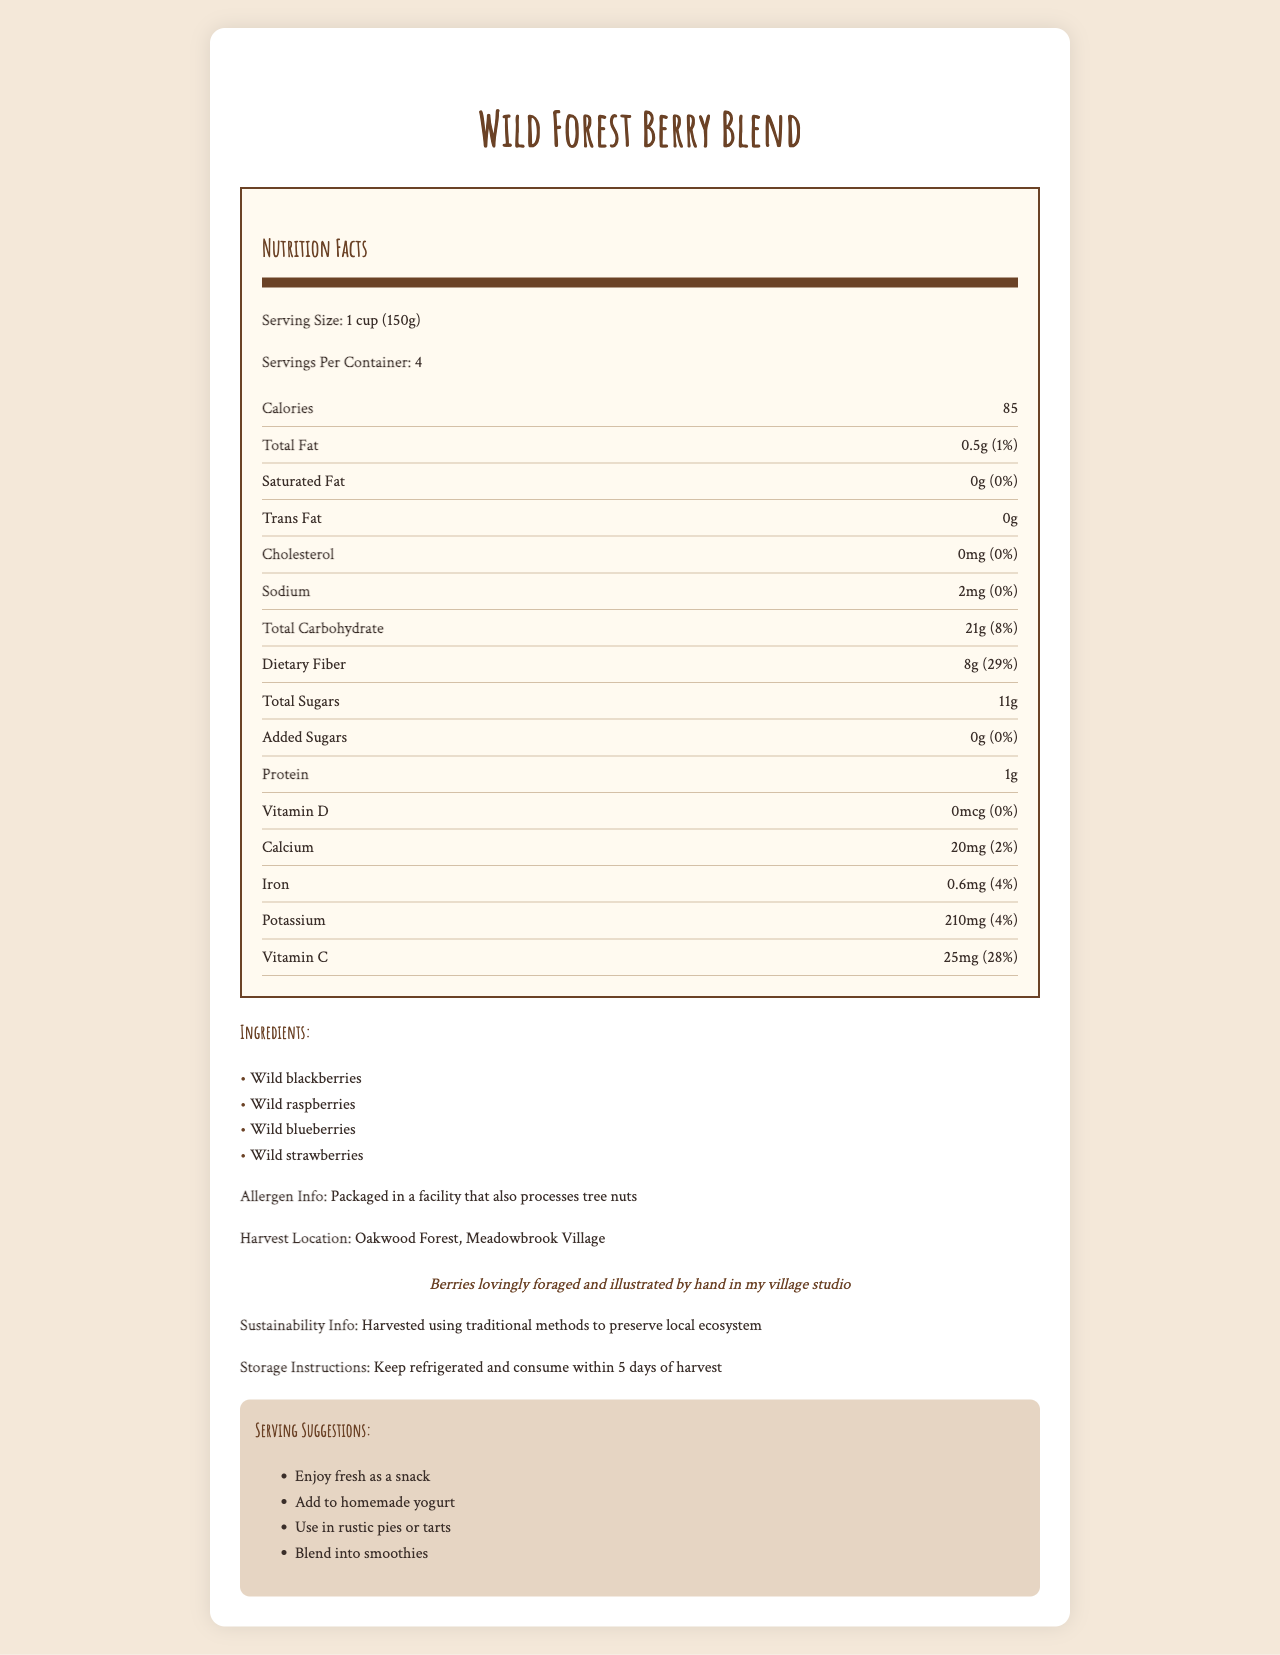What is the serving size for this product? According to the document, the serving size for "Wild Forest Berry Blend" is explicitly mentioned as "1 cup (150g)".
Answer: 1 cup (150g) How many servings are there per container? The document states that there are four servings per container.
Answer: 4 How much Vitamin C is in one serving? The Nutrition Facts show there is 25mg of Vitamin C per serving which equals 28% of the Daily Value.
Answer: 25mg (28% Daily Value) List the berries included in the Wild Forest Berry Blend. The ingredients section lists all the berries included in the blend.
Answer: Wild blackberries, Wild raspberries, Wild blueberries, Wild strawberries What is the amount of dietary fiber per serving? The document specifies the dietary fiber content per serving is 8 grams, which constitutes 29% of the Daily Value.
Answer: 8g (29% Daily Value) Where were the berries harvested? The document mentions that the berries were harvested in Oakwood Forest, Meadowbrook Village.
Answer: Oakwood Forest, Meadowbrook Village Which of the following is true about the total fat content? A. 0g B. 1g C. 0.5g D. 0.2g The document states the total fat content per serving is 0.5g.
Answer: C The hand-drawn illustrations include which type of drawing for blueberries? A. Watercolor painting B. Pencil drawing C. Charcoal sketch D. Ink drawing The document describes the blueberry illustration as a pencil drawing on a branch.
Answer: B Is there added sugar in the Wild Forest Berry Blend? The document states that the added sugars amount to 0g.
Answer: No Summarize the key information provided in this nutrition label document. Describing the entire document reveals comprehensive nutrition information, ingredient details, allergen information, and artistic notes, emphasizing both the nutritional and aesthetic aspects of the product.
Answer: The "Wild Forest Berry Blend" contains various types of wild berries, offering nutritional benefits such as dietary fiber (8g) and Vitamin C (25mg) per serving. It has 85 calories per serving size (1 cup or 150g), with low fat, sodium, and no cholesterol or added sugars. The berries are harvested sustainably from Oakwood Forest and contain possibly mild allergens. This document also includes artistic, hand-drawn illustrations of the individual berries and a forest scene, and it provides several serving suggestions for the blend. What is the calorie content per serving? The nutrition label shows that each serving contains 85 calories.
Answer: 85 calories Which mineral is present in the highest amount? A. Calcium B. Iron C. Potassium D. Vitamin D The document lists potassium at 210mg per serving, which is higher than calcium (20mg), iron (0.6mg), and vitamin D (0mcg).
Answer: C How is the product's sustainability characterized? The document notes that the berries are harvested using traditional methods to maintain the local ecosystem.
Answer: Harvested using traditional methods to preserve the local ecosystem What specific allergen information is provided? The document contains a specific allergen warning stating that the product is packaged in a facility that processes tree nuts.
Answer: Packaged in a facility that also processes tree nuts What is the main idea of the document? By stating this, the document aims to inform the consumer about the health benefits, origin, and artistic aspect of the berry blend.
Answer: To provide detailed nutritional information, ingredient composition, sustainability practices, and serving suggestions for the Wild Forest Berry Blend, along with artistically rendered illustrations of the berries. How much sodium does each serving contain? According to the document, each serving contains 2mg of sodium, which is 0% of the Daily Value.
Answer: 2mg (0% Daily Value) How long can the berries be stored after harvest? The document instructs to keep the berries refrigerated and consume them within 5 days of harvest.
Answer: 5 days What is the artist's favorite berry? The document doesn't provide any personal preferences regarding the artist's favorite berry.
Answer: Not enough information 